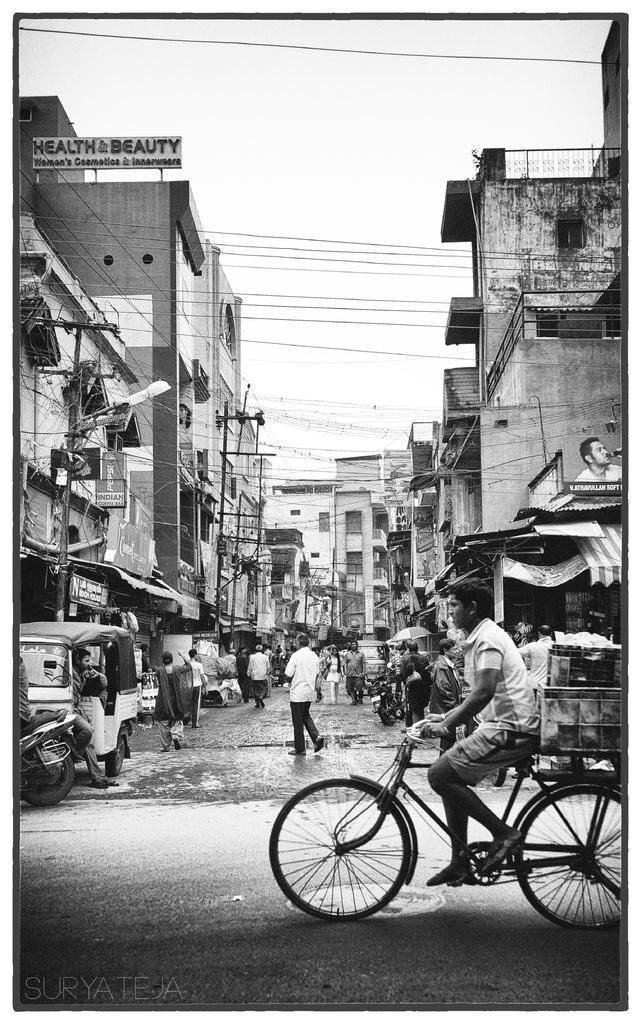Can you describe this image briefly? In this image, On the right side there is a bicycle on that a man is sitting and there is a wooden box on the bicycle and in the left side there is a bike and a passenger car, In the background there are homes. 